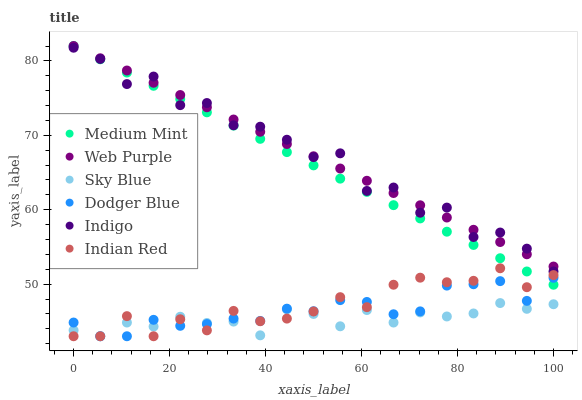Does Sky Blue have the minimum area under the curve?
Answer yes or no. Yes. Does Indigo have the maximum area under the curve?
Answer yes or no. Yes. Does Web Purple have the minimum area under the curve?
Answer yes or no. No. Does Web Purple have the maximum area under the curve?
Answer yes or no. No. Is Web Purple the smoothest?
Answer yes or no. Yes. Is Indigo the roughest?
Answer yes or no. Yes. Is Indigo the smoothest?
Answer yes or no. No. Is Web Purple the roughest?
Answer yes or no. No. Does Dodger Blue have the lowest value?
Answer yes or no. Yes. Does Indigo have the lowest value?
Answer yes or no. No. Does Web Purple have the highest value?
Answer yes or no. Yes. Does Indigo have the highest value?
Answer yes or no. No. Is Indian Red less than Indigo?
Answer yes or no. Yes. Is Web Purple greater than Indian Red?
Answer yes or no. Yes. Does Sky Blue intersect Dodger Blue?
Answer yes or no. Yes. Is Sky Blue less than Dodger Blue?
Answer yes or no. No. Is Sky Blue greater than Dodger Blue?
Answer yes or no. No. Does Indian Red intersect Indigo?
Answer yes or no. No. 